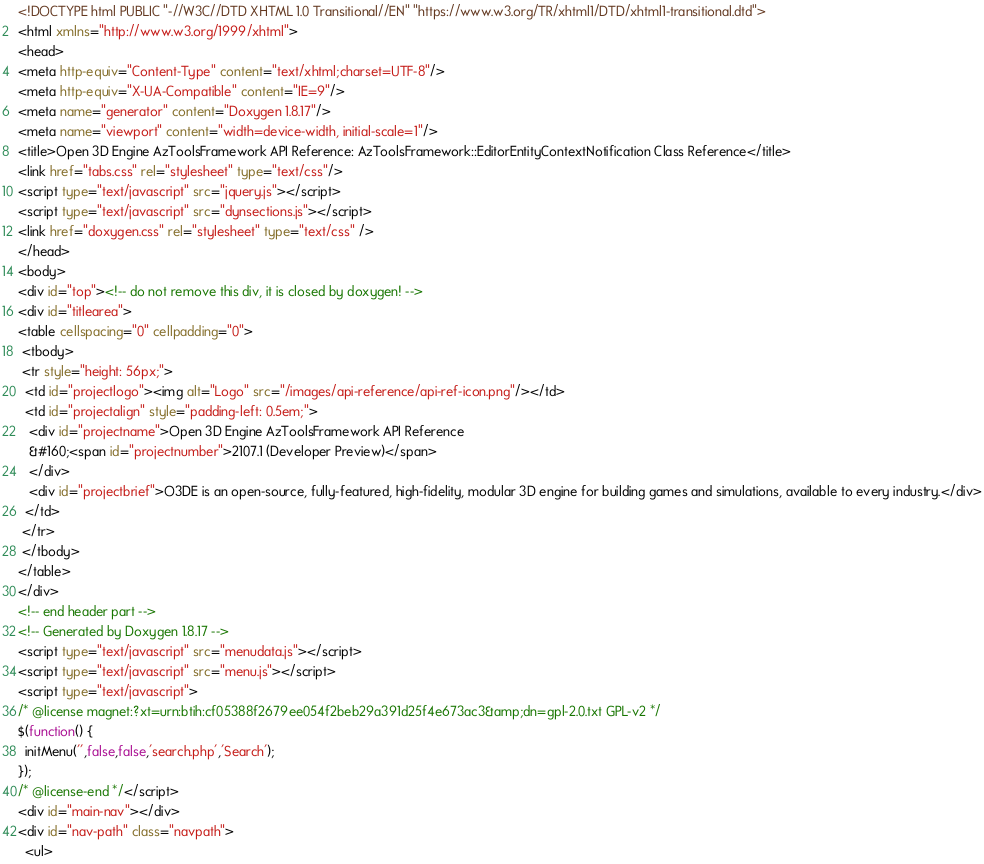<code> <loc_0><loc_0><loc_500><loc_500><_HTML_><!DOCTYPE html PUBLIC "-//W3C//DTD XHTML 1.0 Transitional//EN" "https://www.w3.org/TR/xhtml1/DTD/xhtml1-transitional.dtd">
<html xmlns="http://www.w3.org/1999/xhtml">
<head>
<meta http-equiv="Content-Type" content="text/xhtml;charset=UTF-8"/>
<meta http-equiv="X-UA-Compatible" content="IE=9"/>
<meta name="generator" content="Doxygen 1.8.17"/>
<meta name="viewport" content="width=device-width, initial-scale=1"/>
<title>Open 3D Engine AzToolsFramework API Reference: AzToolsFramework::EditorEntityContextNotification Class Reference</title>
<link href="tabs.css" rel="stylesheet" type="text/css"/>
<script type="text/javascript" src="jquery.js"></script>
<script type="text/javascript" src="dynsections.js"></script>
<link href="doxygen.css" rel="stylesheet" type="text/css" />
</head>
<body>
<div id="top"><!-- do not remove this div, it is closed by doxygen! -->
<div id="titlearea">
<table cellspacing="0" cellpadding="0">
 <tbody>
 <tr style="height: 56px;">
  <td id="projectlogo"><img alt="Logo" src="/images/api-reference/api-ref-icon.png"/></td>
  <td id="projectalign" style="padding-left: 0.5em;">
   <div id="projectname">Open 3D Engine AzToolsFramework API Reference
   &#160;<span id="projectnumber">2107.1 (Developer Preview)</span>
   </div>
   <div id="projectbrief">O3DE is an open-source, fully-featured, high-fidelity, modular 3D engine for building games and simulations, available to every industry.</div>
  </td>
 </tr>
 </tbody>
</table>
</div>
<!-- end header part -->
<!-- Generated by Doxygen 1.8.17 -->
<script type="text/javascript" src="menudata.js"></script>
<script type="text/javascript" src="menu.js"></script>
<script type="text/javascript">
/* @license magnet:?xt=urn:btih:cf05388f2679ee054f2beb29a391d25f4e673ac3&amp;dn=gpl-2.0.txt GPL-v2 */
$(function() {
  initMenu('',false,false,'search.php','Search');
});
/* @license-end */</script>
<div id="main-nav"></div>
<div id="nav-path" class="navpath">
  <ul></code> 